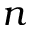<formula> <loc_0><loc_0><loc_500><loc_500>n</formula> 